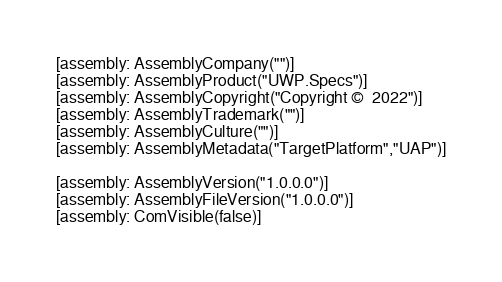Convert code to text. <code><loc_0><loc_0><loc_500><loc_500><_C#_>[assembly: AssemblyCompany("")]
[assembly: AssemblyProduct("UWP.Specs")]
[assembly: AssemblyCopyright("Copyright ©  2022")]
[assembly: AssemblyTrademark("")]
[assembly: AssemblyCulture("")]
[assembly: AssemblyMetadata("TargetPlatform","UAP")]

[assembly: AssemblyVersion("1.0.0.0")]
[assembly: AssemblyFileVersion("1.0.0.0")]
[assembly: ComVisible(false)]</code> 